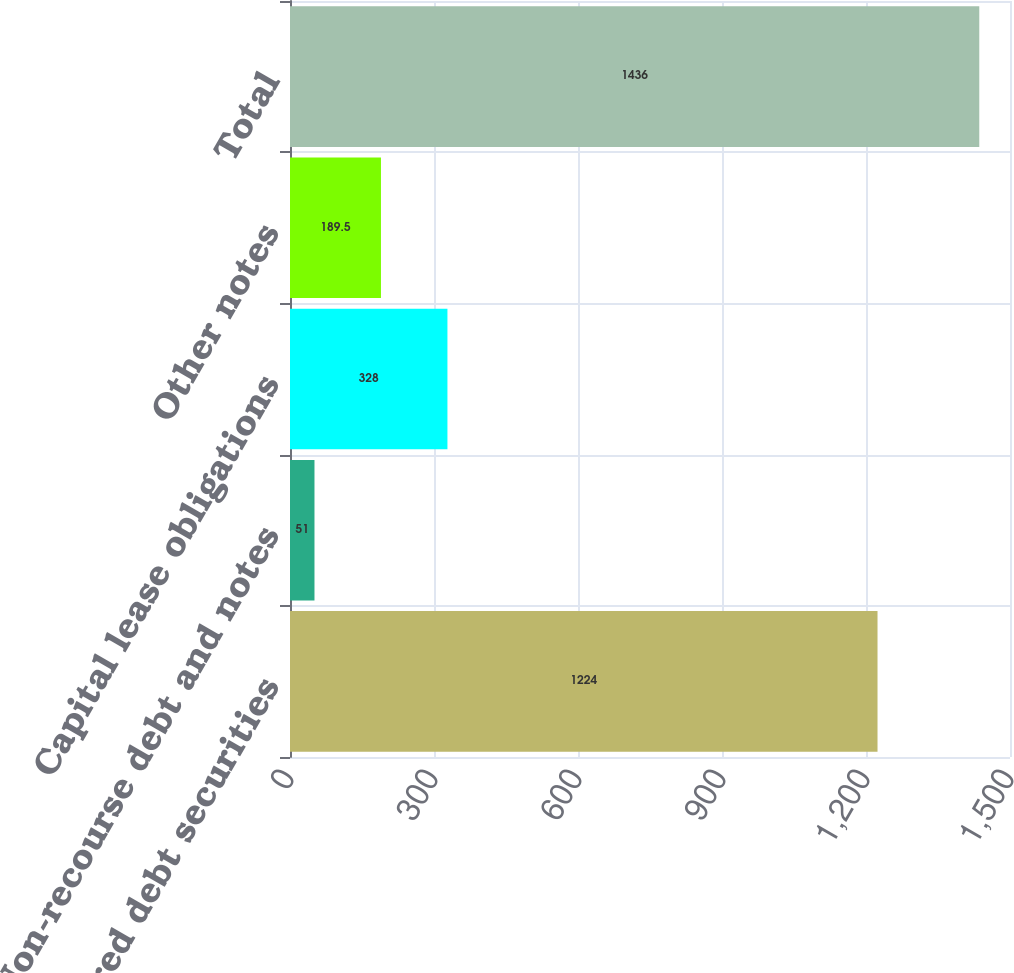Convert chart to OTSL. <chart><loc_0><loc_0><loc_500><loc_500><bar_chart><fcel>Unsecured debt securities<fcel>Non-recourse debt and notes<fcel>Capital lease obligations<fcel>Other notes<fcel>Total<nl><fcel>1224<fcel>51<fcel>328<fcel>189.5<fcel>1436<nl></chart> 